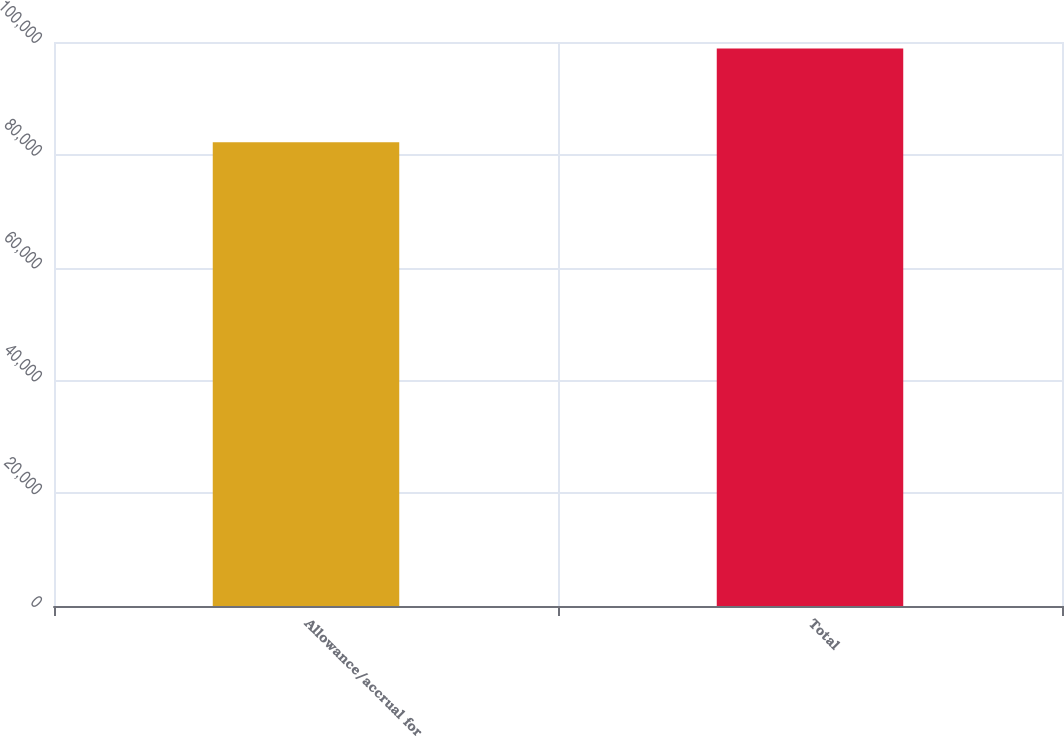Convert chart to OTSL. <chart><loc_0><loc_0><loc_500><loc_500><bar_chart><fcel>Allowance/accrual for<fcel>Total<nl><fcel>82245<fcel>98860<nl></chart> 